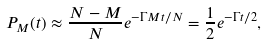Convert formula to latex. <formula><loc_0><loc_0><loc_500><loc_500>P _ { M } ( t ) \approx \frac { N - M } { N } e ^ { - \Gamma M t / N } = \frac { 1 } { 2 } e ^ { - \Gamma t / 2 } ,</formula> 